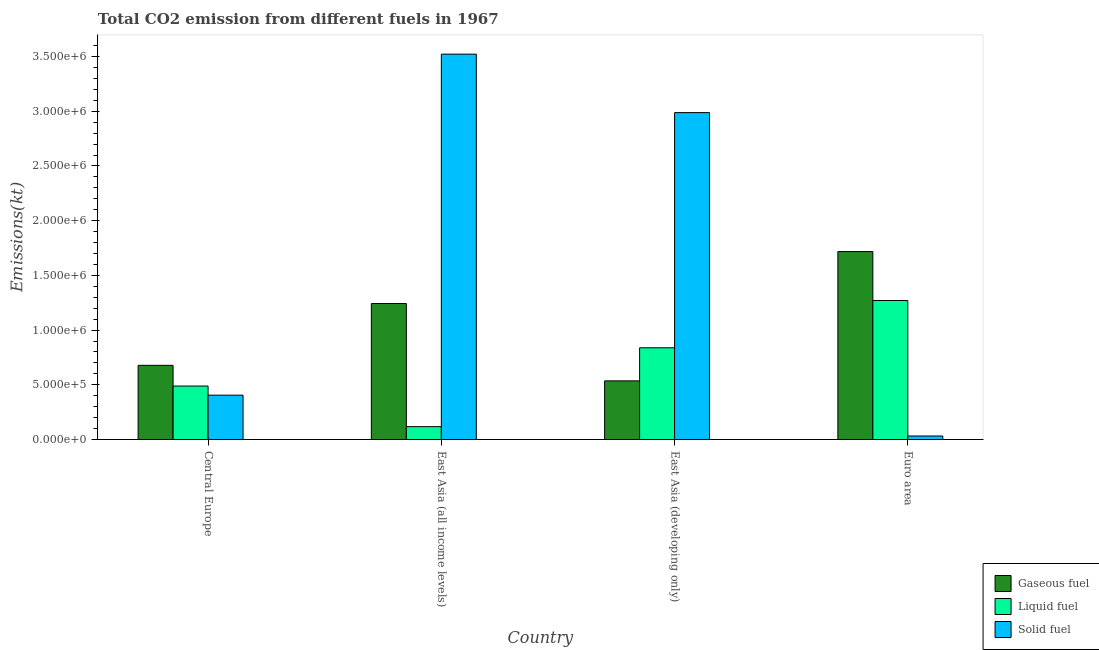How many groups of bars are there?
Give a very brief answer. 4. Are the number of bars on each tick of the X-axis equal?
Give a very brief answer. Yes. How many bars are there on the 4th tick from the left?
Keep it short and to the point. 3. What is the label of the 3rd group of bars from the left?
Give a very brief answer. East Asia (developing only). What is the amount of co2 emissions from solid fuel in Central Europe?
Ensure brevity in your answer.  4.05e+05. Across all countries, what is the maximum amount of co2 emissions from solid fuel?
Offer a very short reply. 3.52e+06. Across all countries, what is the minimum amount of co2 emissions from liquid fuel?
Your answer should be very brief. 1.18e+05. In which country was the amount of co2 emissions from solid fuel maximum?
Ensure brevity in your answer.  East Asia (all income levels). In which country was the amount of co2 emissions from gaseous fuel minimum?
Keep it short and to the point. East Asia (developing only). What is the total amount of co2 emissions from solid fuel in the graph?
Your response must be concise. 6.95e+06. What is the difference between the amount of co2 emissions from solid fuel in Central Europe and that in East Asia (all income levels)?
Offer a very short reply. -3.12e+06. What is the difference between the amount of co2 emissions from gaseous fuel in Euro area and the amount of co2 emissions from liquid fuel in East Asia (all income levels)?
Your answer should be very brief. 1.60e+06. What is the average amount of co2 emissions from solid fuel per country?
Your answer should be very brief. 1.74e+06. What is the difference between the amount of co2 emissions from gaseous fuel and amount of co2 emissions from liquid fuel in East Asia (developing only)?
Your answer should be very brief. -3.02e+05. What is the ratio of the amount of co2 emissions from gaseous fuel in East Asia (developing only) to that in Euro area?
Your answer should be compact. 0.31. Is the difference between the amount of co2 emissions from liquid fuel in Central Europe and East Asia (all income levels) greater than the difference between the amount of co2 emissions from gaseous fuel in Central Europe and East Asia (all income levels)?
Make the answer very short. Yes. What is the difference between the highest and the second highest amount of co2 emissions from solid fuel?
Make the answer very short. 5.34e+05. What is the difference between the highest and the lowest amount of co2 emissions from liquid fuel?
Your response must be concise. 1.15e+06. What does the 3rd bar from the left in Euro area represents?
Your response must be concise. Solid fuel. What does the 1st bar from the right in Euro area represents?
Keep it short and to the point. Solid fuel. How many bars are there?
Your answer should be compact. 12. How many countries are there in the graph?
Offer a very short reply. 4. What is the difference between two consecutive major ticks on the Y-axis?
Give a very brief answer. 5.00e+05. Are the values on the major ticks of Y-axis written in scientific E-notation?
Make the answer very short. Yes. How many legend labels are there?
Provide a succinct answer. 3. What is the title of the graph?
Offer a very short reply. Total CO2 emission from different fuels in 1967. What is the label or title of the Y-axis?
Offer a very short reply. Emissions(kt). What is the Emissions(kt) of Gaseous fuel in Central Europe?
Your response must be concise. 6.78e+05. What is the Emissions(kt) of Liquid fuel in Central Europe?
Your answer should be compact. 4.89e+05. What is the Emissions(kt) in Solid fuel in Central Europe?
Give a very brief answer. 4.05e+05. What is the Emissions(kt) of Gaseous fuel in East Asia (all income levels)?
Give a very brief answer. 1.24e+06. What is the Emissions(kt) in Liquid fuel in East Asia (all income levels)?
Provide a succinct answer. 1.18e+05. What is the Emissions(kt) in Solid fuel in East Asia (all income levels)?
Provide a succinct answer. 3.52e+06. What is the Emissions(kt) in Gaseous fuel in East Asia (developing only)?
Offer a terse response. 5.36e+05. What is the Emissions(kt) of Liquid fuel in East Asia (developing only)?
Keep it short and to the point. 8.38e+05. What is the Emissions(kt) of Solid fuel in East Asia (developing only)?
Offer a terse response. 2.99e+06. What is the Emissions(kt) in Gaseous fuel in Euro area?
Offer a very short reply. 1.72e+06. What is the Emissions(kt) of Liquid fuel in Euro area?
Your answer should be very brief. 1.27e+06. What is the Emissions(kt) in Solid fuel in Euro area?
Keep it short and to the point. 3.21e+04. Across all countries, what is the maximum Emissions(kt) of Gaseous fuel?
Your answer should be compact. 1.72e+06. Across all countries, what is the maximum Emissions(kt) of Liquid fuel?
Offer a terse response. 1.27e+06. Across all countries, what is the maximum Emissions(kt) in Solid fuel?
Offer a very short reply. 3.52e+06. Across all countries, what is the minimum Emissions(kt) of Gaseous fuel?
Your response must be concise. 5.36e+05. Across all countries, what is the minimum Emissions(kt) in Liquid fuel?
Offer a very short reply. 1.18e+05. Across all countries, what is the minimum Emissions(kt) in Solid fuel?
Your answer should be very brief. 3.21e+04. What is the total Emissions(kt) of Gaseous fuel in the graph?
Your answer should be very brief. 4.17e+06. What is the total Emissions(kt) of Liquid fuel in the graph?
Keep it short and to the point. 2.72e+06. What is the total Emissions(kt) of Solid fuel in the graph?
Provide a short and direct response. 6.95e+06. What is the difference between the Emissions(kt) of Gaseous fuel in Central Europe and that in East Asia (all income levels)?
Ensure brevity in your answer.  -5.65e+05. What is the difference between the Emissions(kt) in Liquid fuel in Central Europe and that in East Asia (all income levels)?
Provide a succinct answer. 3.71e+05. What is the difference between the Emissions(kt) of Solid fuel in Central Europe and that in East Asia (all income levels)?
Your answer should be very brief. -3.12e+06. What is the difference between the Emissions(kt) in Gaseous fuel in Central Europe and that in East Asia (developing only)?
Give a very brief answer. 1.42e+05. What is the difference between the Emissions(kt) in Liquid fuel in Central Europe and that in East Asia (developing only)?
Make the answer very short. -3.50e+05. What is the difference between the Emissions(kt) of Solid fuel in Central Europe and that in East Asia (developing only)?
Offer a very short reply. -2.58e+06. What is the difference between the Emissions(kt) of Gaseous fuel in Central Europe and that in Euro area?
Make the answer very short. -1.04e+06. What is the difference between the Emissions(kt) in Liquid fuel in Central Europe and that in Euro area?
Give a very brief answer. -7.82e+05. What is the difference between the Emissions(kt) of Solid fuel in Central Europe and that in Euro area?
Offer a terse response. 3.73e+05. What is the difference between the Emissions(kt) in Gaseous fuel in East Asia (all income levels) and that in East Asia (developing only)?
Offer a terse response. 7.07e+05. What is the difference between the Emissions(kt) of Liquid fuel in East Asia (all income levels) and that in East Asia (developing only)?
Offer a terse response. -7.21e+05. What is the difference between the Emissions(kt) of Solid fuel in East Asia (all income levels) and that in East Asia (developing only)?
Keep it short and to the point. 5.34e+05. What is the difference between the Emissions(kt) of Gaseous fuel in East Asia (all income levels) and that in Euro area?
Ensure brevity in your answer.  -4.75e+05. What is the difference between the Emissions(kt) in Liquid fuel in East Asia (all income levels) and that in Euro area?
Provide a succinct answer. -1.15e+06. What is the difference between the Emissions(kt) in Solid fuel in East Asia (all income levels) and that in Euro area?
Your answer should be compact. 3.49e+06. What is the difference between the Emissions(kt) of Gaseous fuel in East Asia (developing only) and that in Euro area?
Provide a short and direct response. -1.18e+06. What is the difference between the Emissions(kt) of Liquid fuel in East Asia (developing only) and that in Euro area?
Your answer should be very brief. -4.32e+05. What is the difference between the Emissions(kt) of Solid fuel in East Asia (developing only) and that in Euro area?
Provide a succinct answer. 2.96e+06. What is the difference between the Emissions(kt) of Gaseous fuel in Central Europe and the Emissions(kt) of Liquid fuel in East Asia (all income levels)?
Make the answer very short. 5.60e+05. What is the difference between the Emissions(kt) in Gaseous fuel in Central Europe and the Emissions(kt) in Solid fuel in East Asia (all income levels)?
Your answer should be very brief. -2.84e+06. What is the difference between the Emissions(kt) of Liquid fuel in Central Europe and the Emissions(kt) of Solid fuel in East Asia (all income levels)?
Offer a terse response. -3.03e+06. What is the difference between the Emissions(kt) of Gaseous fuel in Central Europe and the Emissions(kt) of Liquid fuel in East Asia (developing only)?
Provide a succinct answer. -1.60e+05. What is the difference between the Emissions(kt) in Gaseous fuel in Central Europe and the Emissions(kt) in Solid fuel in East Asia (developing only)?
Ensure brevity in your answer.  -2.31e+06. What is the difference between the Emissions(kt) in Liquid fuel in Central Europe and the Emissions(kt) in Solid fuel in East Asia (developing only)?
Your answer should be compact. -2.50e+06. What is the difference between the Emissions(kt) of Gaseous fuel in Central Europe and the Emissions(kt) of Liquid fuel in Euro area?
Make the answer very short. -5.93e+05. What is the difference between the Emissions(kt) in Gaseous fuel in Central Europe and the Emissions(kt) in Solid fuel in Euro area?
Ensure brevity in your answer.  6.46e+05. What is the difference between the Emissions(kt) of Liquid fuel in Central Europe and the Emissions(kt) of Solid fuel in Euro area?
Your answer should be very brief. 4.57e+05. What is the difference between the Emissions(kt) of Gaseous fuel in East Asia (all income levels) and the Emissions(kt) of Liquid fuel in East Asia (developing only)?
Your answer should be very brief. 4.04e+05. What is the difference between the Emissions(kt) of Gaseous fuel in East Asia (all income levels) and the Emissions(kt) of Solid fuel in East Asia (developing only)?
Your response must be concise. -1.74e+06. What is the difference between the Emissions(kt) of Liquid fuel in East Asia (all income levels) and the Emissions(kt) of Solid fuel in East Asia (developing only)?
Your answer should be very brief. -2.87e+06. What is the difference between the Emissions(kt) in Gaseous fuel in East Asia (all income levels) and the Emissions(kt) in Liquid fuel in Euro area?
Provide a short and direct response. -2.77e+04. What is the difference between the Emissions(kt) in Gaseous fuel in East Asia (all income levels) and the Emissions(kt) in Solid fuel in Euro area?
Ensure brevity in your answer.  1.21e+06. What is the difference between the Emissions(kt) in Liquid fuel in East Asia (all income levels) and the Emissions(kt) in Solid fuel in Euro area?
Give a very brief answer. 8.56e+04. What is the difference between the Emissions(kt) of Gaseous fuel in East Asia (developing only) and the Emissions(kt) of Liquid fuel in Euro area?
Give a very brief answer. -7.35e+05. What is the difference between the Emissions(kt) in Gaseous fuel in East Asia (developing only) and the Emissions(kt) in Solid fuel in Euro area?
Offer a terse response. 5.04e+05. What is the difference between the Emissions(kt) of Liquid fuel in East Asia (developing only) and the Emissions(kt) of Solid fuel in Euro area?
Give a very brief answer. 8.06e+05. What is the average Emissions(kt) in Gaseous fuel per country?
Keep it short and to the point. 1.04e+06. What is the average Emissions(kt) of Liquid fuel per country?
Your response must be concise. 6.79e+05. What is the average Emissions(kt) of Solid fuel per country?
Offer a very short reply. 1.74e+06. What is the difference between the Emissions(kt) of Gaseous fuel and Emissions(kt) of Liquid fuel in Central Europe?
Provide a succinct answer. 1.89e+05. What is the difference between the Emissions(kt) in Gaseous fuel and Emissions(kt) in Solid fuel in Central Europe?
Offer a terse response. 2.73e+05. What is the difference between the Emissions(kt) of Liquid fuel and Emissions(kt) of Solid fuel in Central Europe?
Offer a very short reply. 8.34e+04. What is the difference between the Emissions(kt) of Gaseous fuel and Emissions(kt) of Liquid fuel in East Asia (all income levels)?
Your response must be concise. 1.13e+06. What is the difference between the Emissions(kt) in Gaseous fuel and Emissions(kt) in Solid fuel in East Asia (all income levels)?
Offer a terse response. -2.28e+06. What is the difference between the Emissions(kt) of Liquid fuel and Emissions(kt) of Solid fuel in East Asia (all income levels)?
Offer a very short reply. -3.40e+06. What is the difference between the Emissions(kt) of Gaseous fuel and Emissions(kt) of Liquid fuel in East Asia (developing only)?
Make the answer very short. -3.02e+05. What is the difference between the Emissions(kt) in Gaseous fuel and Emissions(kt) in Solid fuel in East Asia (developing only)?
Give a very brief answer. -2.45e+06. What is the difference between the Emissions(kt) in Liquid fuel and Emissions(kt) in Solid fuel in East Asia (developing only)?
Keep it short and to the point. -2.15e+06. What is the difference between the Emissions(kt) of Gaseous fuel and Emissions(kt) of Liquid fuel in Euro area?
Keep it short and to the point. 4.47e+05. What is the difference between the Emissions(kt) of Gaseous fuel and Emissions(kt) of Solid fuel in Euro area?
Provide a short and direct response. 1.69e+06. What is the difference between the Emissions(kt) of Liquid fuel and Emissions(kt) of Solid fuel in Euro area?
Keep it short and to the point. 1.24e+06. What is the ratio of the Emissions(kt) in Gaseous fuel in Central Europe to that in East Asia (all income levels)?
Provide a succinct answer. 0.55. What is the ratio of the Emissions(kt) in Liquid fuel in Central Europe to that in East Asia (all income levels)?
Give a very brief answer. 4.15. What is the ratio of the Emissions(kt) in Solid fuel in Central Europe to that in East Asia (all income levels)?
Your response must be concise. 0.12. What is the ratio of the Emissions(kt) of Gaseous fuel in Central Europe to that in East Asia (developing only)?
Your response must be concise. 1.26. What is the ratio of the Emissions(kt) of Liquid fuel in Central Europe to that in East Asia (developing only)?
Your answer should be very brief. 0.58. What is the ratio of the Emissions(kt) in Solid fuel in Central Europe to that in East Asia (developing only)?
Provide a succinct answer. 0.14. What is the ratio of the Emissions(kt) of Gaseous fuel in Central Europe to that in Euro area?
Your answer should be very brief. 0.39. What is the ratio of the Emissions(kt) in Liquid fuel in Central Europe to that in Euro area?
Provide a succinct answer. 0.38. What is the ratio of the Emissions(kt) in Solid fuel in Central Europe to that in Euro area?
Your answer should be very brief. 12.62. What is the ratio of the Emissions(kt) of Gaseous fuel in East Asia (all income levels) to that in East Asia (developing only)?
Make the answer very short. 2.32. What is the ratio of the Emissions(kt) in Liquid fuel in East Asia (all income levels) to that in East Asia (developing only)?
Provide a succinct answer. 0.14. What is the ratio of the Emissions(kt) in Solid fuel in East Asia (all income levels) to that in East Asia (developing only)?
Provide a short and direct response. 1.18. What is the ratio of the Emissions(kt) in Gaseous fuel in East Asia (all income levels) to that in Euro area?
Provide a short and direct response. 0.72. What is the ratio of the Emissions(kt) in Liquid fuel in East Asia (all income levels) to that in Euro area?
Make the answer very short. 0.09. What is the ratio of the Emissions(kt) of Solid fuel in East Asia (all income levels) to that in Euro area?
Your answer should be compact. 109.68. What is the ratio of the Emissions(kt) in Gaseous fuel in East Asia (developing only) to that in Euro area?
Make the answer very short. 0.31. What is the ratio of the Emissions(kt) of Liquid fuel in East Asia (developing only) to that in Euro area?
Provide a short and direct response. 0.66. What is the ratio of the Emissions(kt) of Solid fuel in East Asia (developing only) to that in Euro area?
Ensure brevity in your answer.  93.04. What is the difference between the highest and the second highest Emissions(kt) of Gaseous fuel?
Ensure brevity in your answer.  4.75e+05. What is the difference between the highest and the second highest Emissions(kt) of Liquid fuel?
Offer a terse response. 4.32e+05. What is the difference between the highest and the second highest Emissions(kt) of Solid fuel?
Your answer should be very brief. 5.34e+05. What is the difference between the highest and the lowest Emissions(kt) in Gaseous fuel?
Your answer should be compact. 1.18e+06. What is the difference between the highest and the lowest Emissions(kt) in Liquid fuel?
Offer a very short reply. 1.15e+06. What is the difference between the highest and the lowest Emissions(kt) of Solid fuel?
Give a very brief answer. 3.49e+06. 